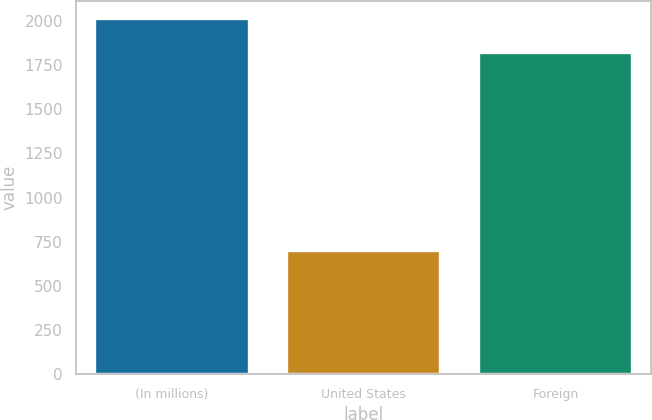<chart> <loc_0><loc_0><loc_500><loc_500><bar_chart><fcel>(In millions)<fcel>United States<fcel>Foreign<nl><fcel>2010<fcel>699<fcel>1818<nl></chart> 